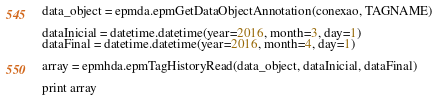Convert code to text. <code><loc_0><loc_0><loc_500><loc_500><_Python_>data_object = epmda.epmGetDataObjectAnnotation(conexao, TAGNAME)

dataInicial = datetime.datetime(year=2016, month=3, day=1)
dataFinal = datetime.datetime(year=2016, month=4, day=1)

array = epmhda.epmTagHistoryRead(data_object, dataInicial, dataFinal)

print array
</code> 